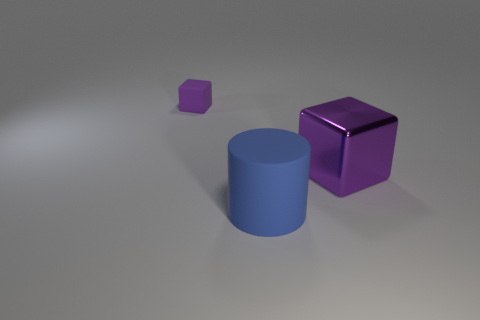There is a thing right of the big cylinder in front of the purple object right of the purple matte block; what is it made of?
Offer a very short reply. Metal. The big rubber thing is what color?
Offer a terse response. Blue. What number of small objects are rubber things or blue matte things?
Provide a succinct answer. 1. There is another block that is the same color as the tiny rubber block; what material is it?
Provide a succinct answer. Metal. Does the purple cube that is on the left side of the large blue cylinder have the same material as the big thing on the left side of the metallic object?
Provide a short and direct response. Yes. Are there any small yellow rubber cylinders?
Your answer should be compact. No. Are there more large blue matte cylinders that are in front of the purple metal cube than purple matte objects in front of the large matte cylinder?
Your answer should be very brief. Yes. What material is the other thing that is the same shape as the purple rubber object?
Provide a succinct answer. Metal. Is there anything else that is the same size as the matte cube?
Provide a short and direct response. No. There is a block behind the large purple metal cube; is its color the same as the cube in front of the small purple rubber block?
Your response must be concise. Yes. 